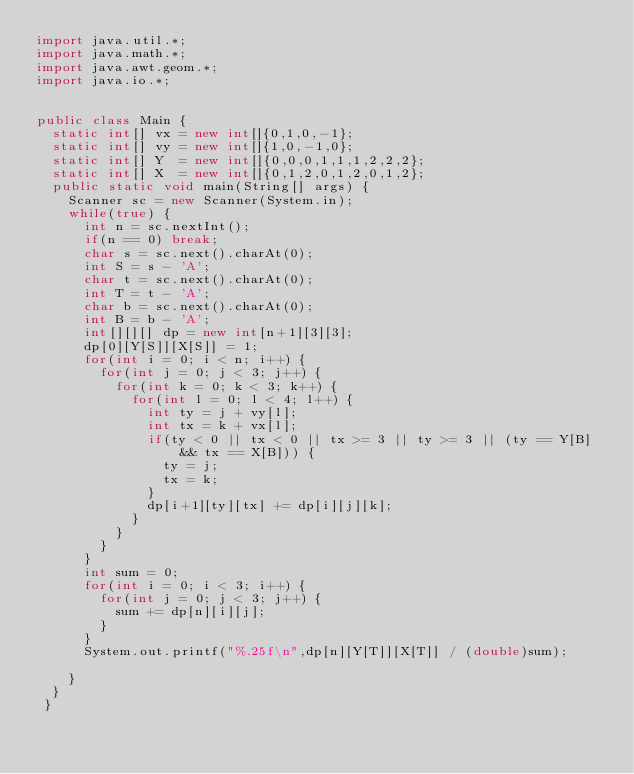Convert code to text. <code><loc_0><loc_0><loc_500><loc_500><_Java_>import java.util.*;
import java.math.*;
import java.awt.geom.*;
import java.io.*;
      
      
public class Main {
	static int[] vx = new int[]{0,1,0,-1};
	static int[] vy = new int[]{1,0,-1,0};
	static int[] Y  = new int[]{0,0,0,1,1,1,2,2,2};
	static int[] X  = new int[]{0,1,2,0,1,2,0,1,2};
	public static void main(String[] args) {
		Scanner sc = new Scanner(System.in);
		while(true) {
			int n = sc.nextInt();
			if(n == 0) break;
			char s = sc.next().charAt(0);
			int S = s - 'A';
			char t = sc.next().charAt(0);
			int T = t - 'A';
			char b = sc.next().charAt(0);
			int B = b - 'A';
			int[][][] dp = new int[n+1][3][3];
			dp[0][Y[S]][X[S]] = 1;
			for(int i = 0; i < n; i++) {
				for(int j = 0; j < 3; j++) {
					for(int k = 0; k < 3; k++) {
						for(int l = 0; l < 4; l++) {
							int ty = j + vy[l];
							int tx = k + vx[l];
							if(ty < 0 || tx < 0 || tx >= 3 || ty >= 3 || (ty == Y[B] && tx == X[B])) {
								ty = j;
								tx = k;
							}
							dp[i+1][ty][tx] += dp[i][j][k];
						}
					}
				}
			}
			int sum = 0;
			for(int i = 0; i < 3; i++) {
				for(int j = 0; j < 3; j++) {
					sum += dp[n][i][j];
				}
			}
			System.out.printf("%.25f\n",dp[n][Y[T]][X[T]] / (double)sum);
			
		}
	}
 }</code> 